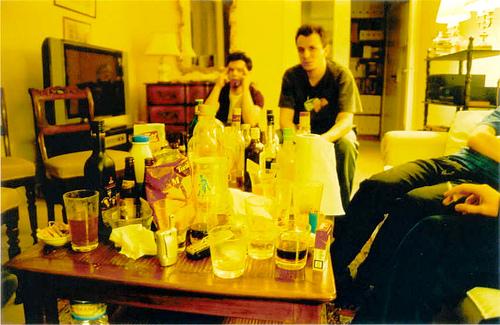Is there a TV set on?
Quick response, please. Yes. How many people are shown holding cigarettes?
Give a very brief answer. 1. Is this a messy table?
Give a very brief answer. Yes. 